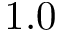Convert formula to latex. <formula><loc_0><loc_0><loc_500><loc_500>1 . 0</formula> 